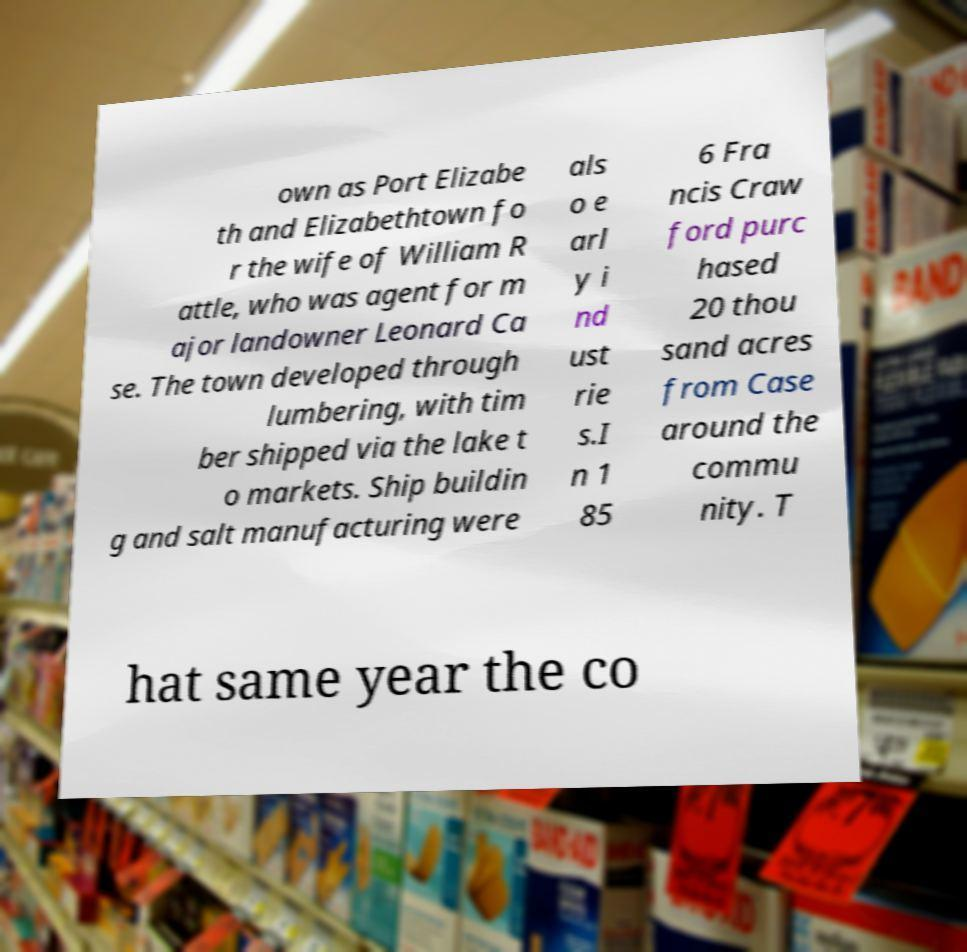Please read and relay the text visible in this image. What does it say? own as Port Elizabe th and Elizabethtown fo r the wife of William R attle, who was agent for m ajor landowner Leonard Ca se. The town developed through lumbering, with tim ber shipped via the lake t o markets. Ship buildin g and salt manufacturing were als o e arl y i nd ust rie s.I n 1 85 6 Fra ncis Craw ford purc hased 20 thou sand acres from Case around the commu nity. T hat same year the co 